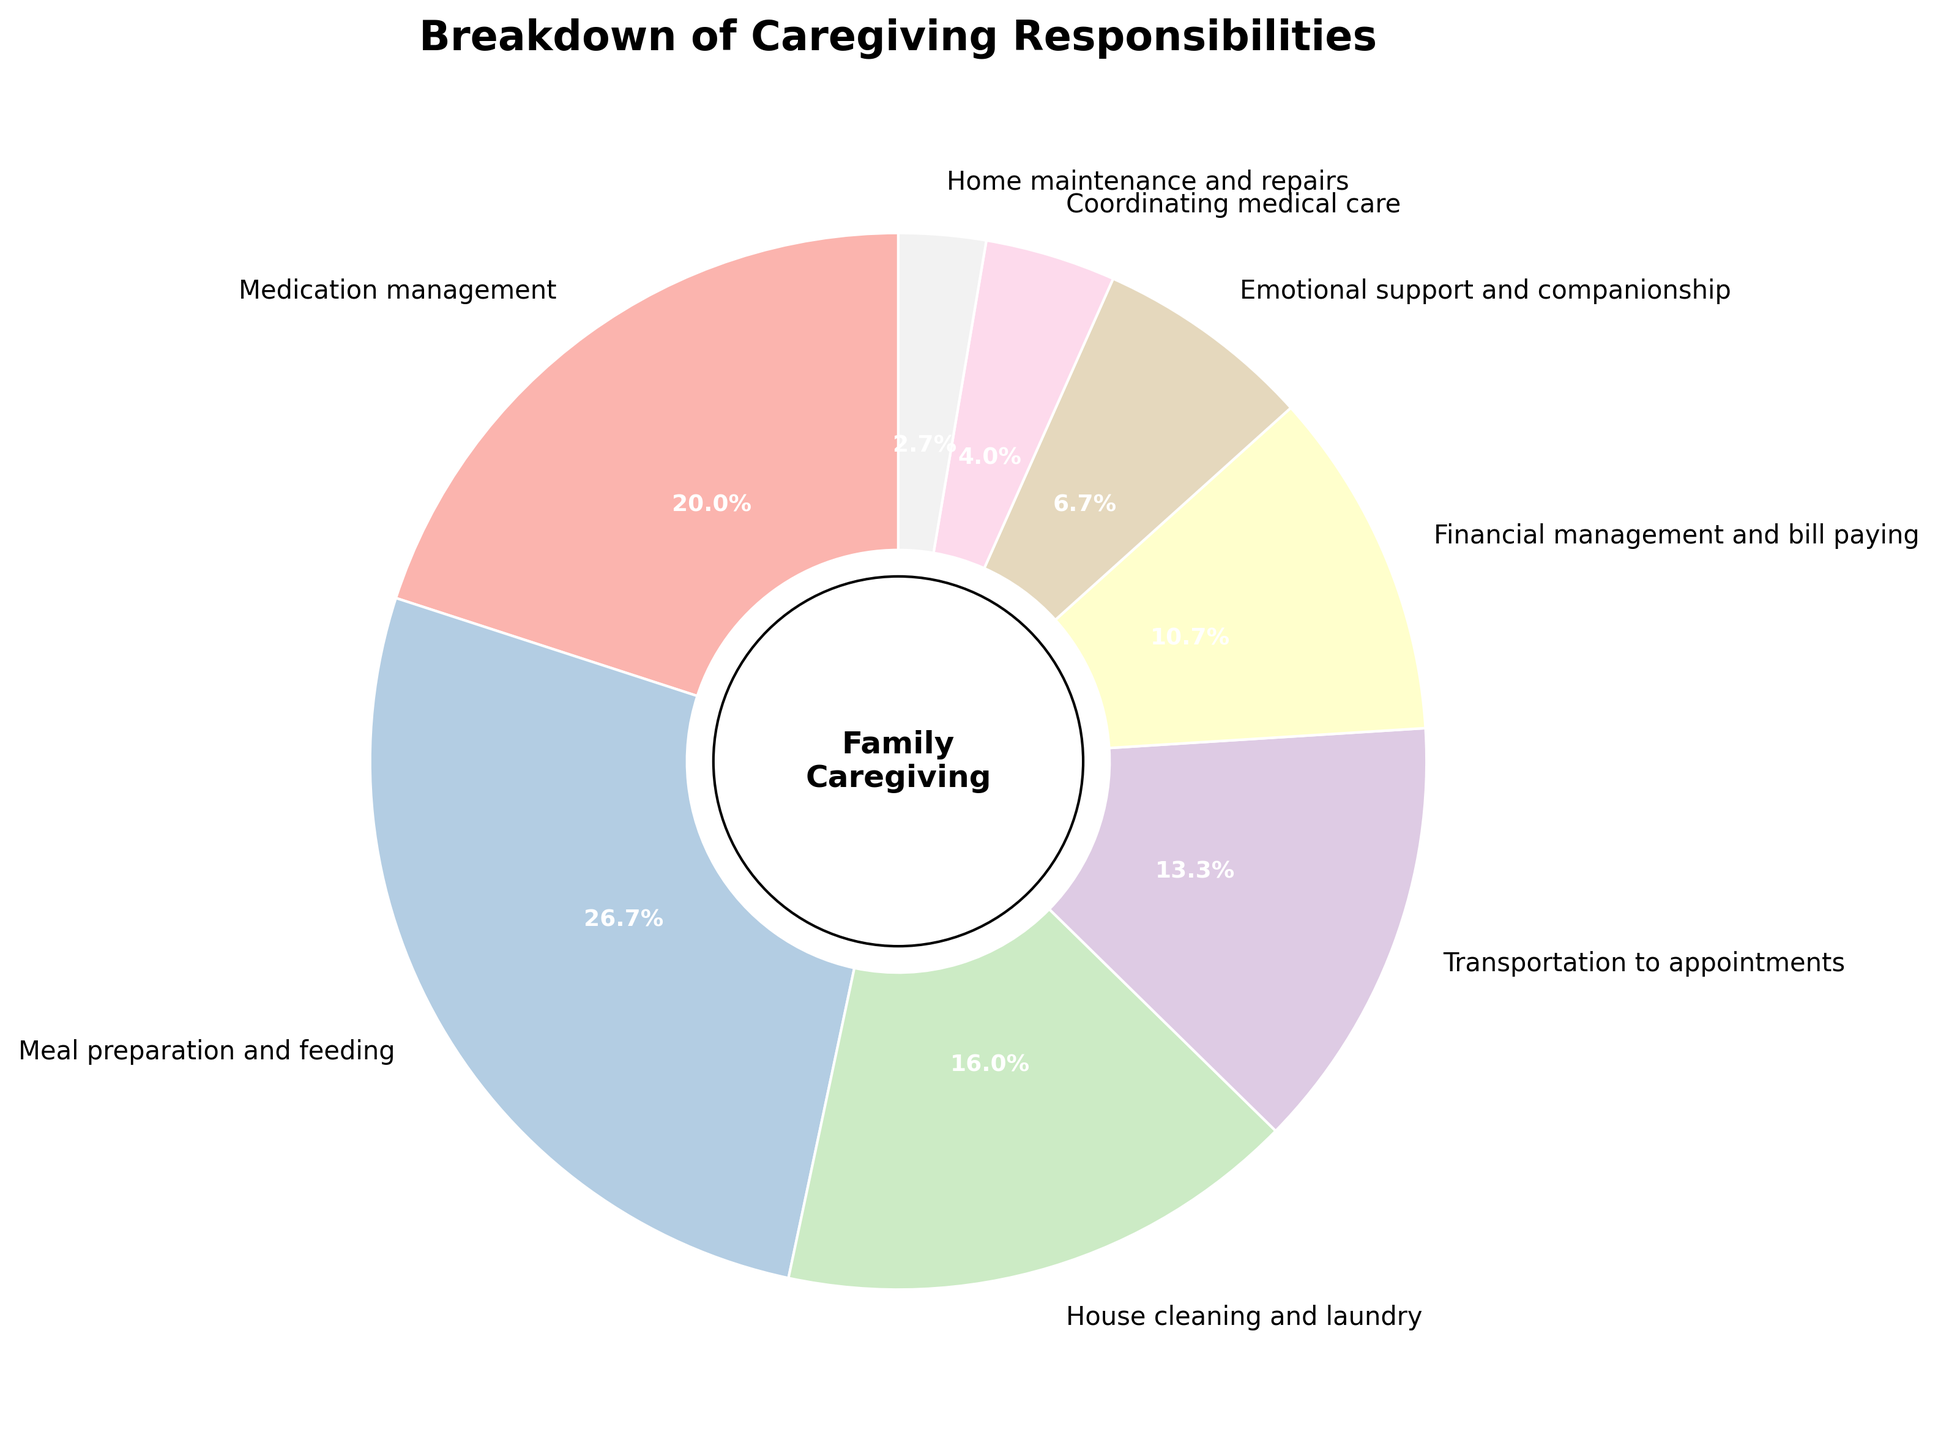Which caregiving responsibility has the highest percentage? The pie chart shows various caregiving responsibilities with their respective percentages. The section labeled "Meal preparation and feeding" has the highest percentage at 20%.
Answer: Meal preparation and feeding What is the combined percentage for House cleaning and laundry, and Transportation to appointments? To find the combined percentage, add the percentages for House cleaning and laundry (12%) and Transportation to appointments (10%): 12% + 10% = 22%.
Answer: 22% Which caregiving responsibilities have a percentage of less than 10%? The pie chart shows that Financial management and bill paying (8%), Emotional support and companionship (5%), Coordinating medical care (3%), and Home maintenance and repairs (2%) all have percentages less than 10%.
Answer: Financial management and bill paying, Emotional support and companionship, Coordinating medical care, Home maintenance and repairs How many caregiving responsibilities have a higher percentage compared to Transportation to appointments? Transportation to appointments has a percentage of 10%. The caregiving responsibilities with higher percentages are Medication management (15%), Meal preparation and feeding (20%), and House cleaning and laundry (12%). There are 3 caregiving responsibilities with higher percentages.
Answer: 3 Is the percentage for Home maintenance and repairs more or less than half the percentage for Medication management? The percentage for Home maintenance and repairs is 2%, and the percentage for Medication management is 15%. Half of 15% is 7.5%. Since 2% is less than 7.5%, Home maintenance and repairs is less than half the percentage for Medication management.
Answer: Less Which category has the smallest percentage and what is it? The pie chart displays the various caregiving responsibilities and their percentages. The section labeled "Home maintenance and repairs" has the smallest percentage at 2%.
Answer: Home maintenance and repairs, 2% What is the total percentage for the responsibilities related to managing aspects of the household (House cleaning and laundry, Financial management and bill paying, Home maintenance and repairs)? Add the percentages for House cleaning and laundry (12%), Financial management and bill paying (8%), and Home maintenance and repairs (2%): 12% + 8% + 2% = 22%.
Answer: 22% What is the difference between the highest and the lowest percentages in the chart? The highest percentage is for Meal preparation and feeding at 20%, and the lowest is for Home maintenance and repairs at 2%. The difference is 20% - 2% = 18%.
Answer: 18% Three caregiving responsibilities combined equal the percentage of Meal preparation and feeding, which are they? Meal preparation and feeding is 20%. We need three responsibilities whose percentages add up to 20%. These are House cleaning and laundry (12%), Emotional support and companionship (5%), and Home maintenance and repairs (2%): 12% + 5% + 2% = 19%. This doesn't work. Let's try another combination: Transportation to appointments (10%), Financial management and bill paying (8%), and Coordinating medical care (3%): 10% + 8% + 3% = 21%. This is too high. Combining Emotional support and companionship (5%), Coordinating medical care (3%), and Home maintenance and repairs (2%) gives 5% + 3% + 2% = 10%, which is too low. Finally, combining Transportation to appointments (10%), Emotional support and companionship (5%), Financial management and bill paying (8%) gives 10% + 5% + 8% = 23%, also incorrect. After review, it seems no exact combination of three responsibilities equal 20%.
Answer: None exact 